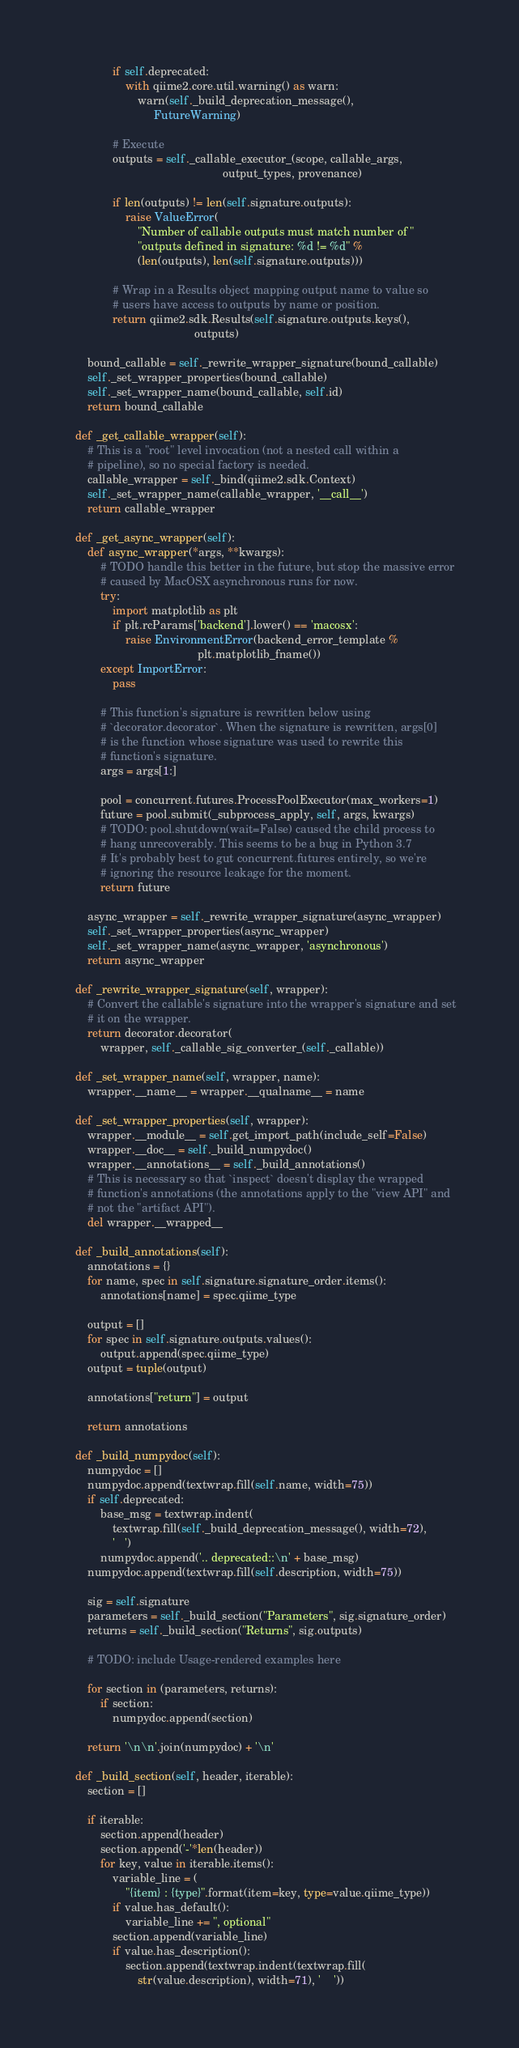<code> <loc_0><loc_0><loc_500><loc_500><_Python_>
                if self.deprecated:
                    with qiime2.core.util.warning() as warn:
                        warn(self._build_deprecation_message(),
                             FutureWarning)

                # Execute
                outputs = self._callable_executor_(scope, callable_args,
                                                   output_types, provenance)

                if len(outputs) != len(self.signature.outputs):
                    raise ValueError(
                        "Number of callable outputs must match number of "
                        "outputs defined in signature: %d != %d" %
                        (len(outputs), len(self.signature.outputs)))

                # Wrap in a Results object mapping output name to value so
                # users have access to outputs by name or position.
                return qiime2.sdk.Results(self.signature.outputs.keys(),
                                          outputs)

        bound_callable = self._rewrite_wrapper_signature(bound_callable)
        self._set_wrapper_properties(bound_callable)
        self._set_wrapper_name(bound_callable, self.id)
        return bound_callable

    def _get_callable_wrapper(self):
        # This is a "root" level invocation (not a nested call within a
        # pipeline), so no special factory is needed.
        callable_wrapper = self._bind(qiime2.sdk.Context)
        self._set_wrapper_name(callable_wrapper, '__call__')
        return callable_wrapper

    def _get_async_wrapper(self):
        def async_wrapper(*args, **kwargs):
            # TODO handle this better in the future, but stop the massive error
            # caused by MacOSX asynchronous runs for now.
            try:
                import matplotlib as plt
                if plt.rcParams['backend'].lower() == 'macosx':
                    raise EnvironmentError(backend_error_template %
                                           plt.matplotlib_fname())
            except ImportError:
                pass

            # This function's signature is rewritten below using
            # `decorator.decorator`. When the signature is rewritten, args[0]
            # is the function whose signature was used to rewrite this
            # function's signature.
            args = args[1:]

            pool = concurrent.futures.ProcessPoolExecutor(max_workers=1)
            future = pool.submit(_subprocess_apply, self, args, kwargs)
            # TODO: pool.shutdown(wait=False) caused the child process to
            # hang unrecoverably. This seems to be a bug in Python 3.7
            # It's probably best to gut concurrent.futures entirely, so we're
            # ignoring the resource leakage for the moment.
            return future

        async_wrapper = self._rewrite_wrapper_signature(async_wrapper)
        self._set_wrapper_properties(async_wrapper)
        self._set_wrapper_name(async_wrapper, 'asynchronous')
        return async_wrapper

    def _rewrite_wrapper_signature(self, wrapper):
        # Convert the callable's signature into the wrapper's signature and set
        # it on the wrapper.
        return decorator.decorator(
            wrapper, self._callable_sig_converter_(self._callable))

    def _set_wrapper_name(self, wrapper, name):
        wrapper.__name__ = wrapper.__qualname__ = name

    def _set_wrapper_properties(self, wrapper):
        wrapper.__module__ = self.get_import_path(include_self=False)
        wrapper.__doc__ = self._build_numpydoc()
        wrapper.__annotations__ = self._build_annotations()
        # This is necessary so that `inspect` doesn't display the wrapped
        # function's annotations (the annotations apply to the "view API" and
        # not the "artifact API").
        del wrapper.__wrapped__

    def _build_annotations(self):
        annotations = {}
        for name, spec in self.signature.signature_order.items():
            annotations[name] = spec.qiime_type

        output = []
        for spec in self.signature.outputs.values():
            output.append(spec.qiime_type)
        output = tuple(output)

        annotations["return"] = output

        return annotations

    def _build_numpydoc(self):
        numpydoc = []
        numpydoc.append(textwrap.fill(self.name, width=75))
        if self.deprecated:
            base_msg = textwrap.indent(
                textwrap.fill(self._build_deprecation_message(), width=72),
                '   ')
            numpydoc.append('.. deprecated::\n' + base_msg)
        numpydoc.append(textwrap.fill(self.description, width=75))

        sig = self.signature
        parameters = self._build_section("Parameters", sig.signature_order)
        returns = self._build_section("Returns", sig.outputs)

        # TODO: include Usage-rendered examples here

        for section in (parameters, returns):
            if section:
                numpydoc.append(section)

        return '\n\n'.join(numpydoc) + '\n'

    def _build_section(self, header, iterable):
        section = []

        if iterable:
            section.append(header)
            section.append('-'*len(header))
            for key, value in iterable.items():
                variable_line = (
                    "{item} : {type}".format(item=key, type=value.qiime_type))
                if value.has_default():
                    variable_line += ", optional"
                section.append(variable_line)
                if value.has_description():
                    section.append(textwrap.indent(textwrap.fill(
                        str(value.description), width=71), '    '))
</code> 